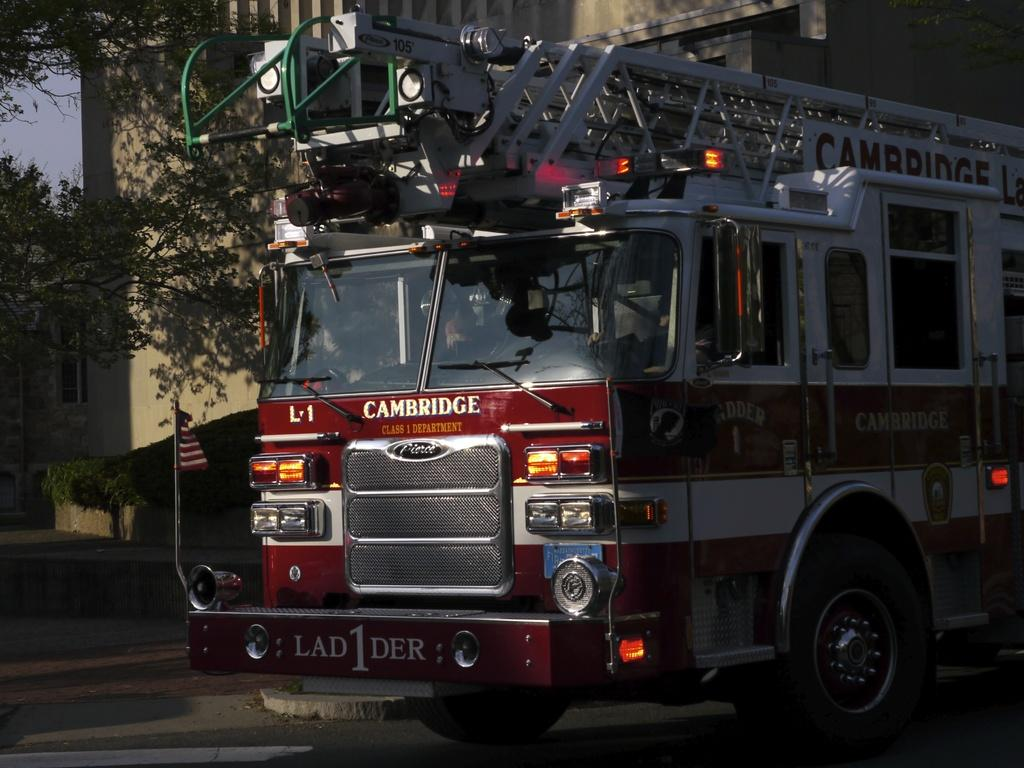What type of vehicle is in the image? There is a red truck in the image. What is at the bottom of the image? There is a road at the bottom of the image. What can be seen on the left side of the image? There are trees on the left side of the image. What is visible in the background of the image? There is a building in the background of the image. Is there a spy observing the red truck in the image? There is no indication of a spy or any person observing the red truck in the image. 